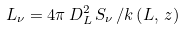Convert formula to latex. <formula><loc_0><loc_0><loc_500><loc_500>L _ { \nu } = 4 \pi \, D _ { L } ^ { 2 } \, S _ { \nu } \, / k \left ( L , \, z \right )</formula> 